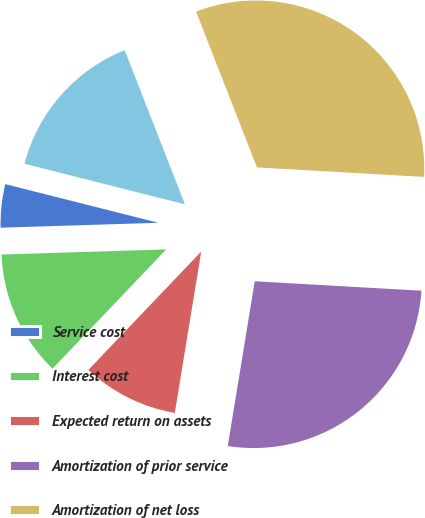Convert chart to OTSL. <chart><loc_0><loc_0><loc_500><loc_500><pie_chart><fcel>Service cost<fcel>Interest cost<fcel>Expected return on assets<fcel>Amortization of prior service<fcel>Amortization of net loss<fcel>Net periodic benefit cost<nl><fcel>4.43%<fcel>12.39%<fcel>9.53%<fcel>26.68%<fcel>31.83%<fcel>15.13%<nl></chart> 